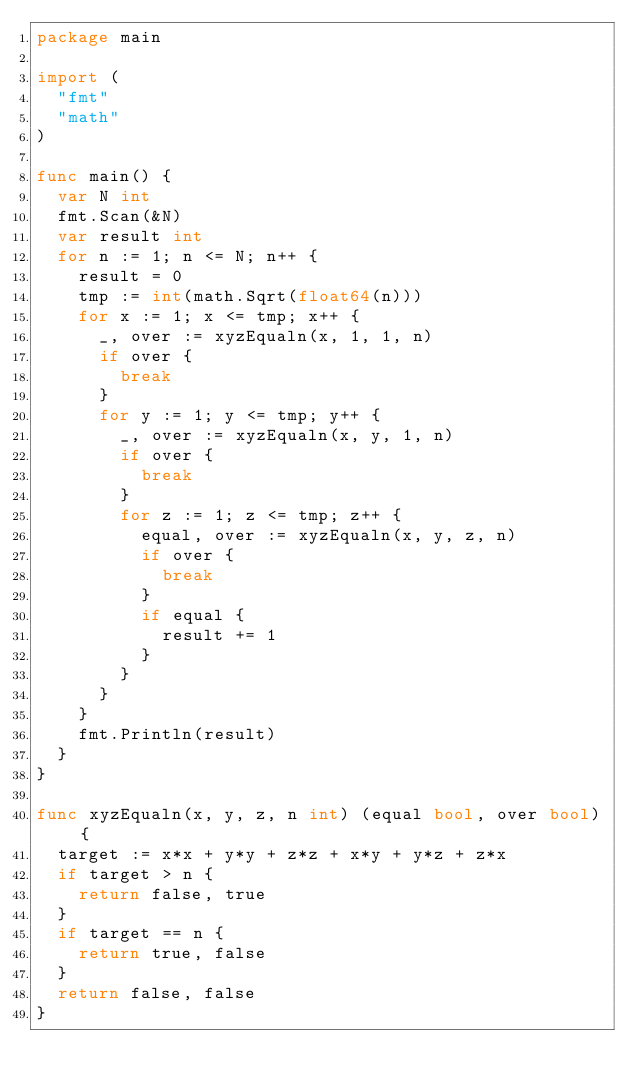Convert code to text. <code><loc_0><loc_0><loc_500><loc_500><_Go_>package main

import (
	"fmt"
	"math"
)

func main() {
	var N int
	fmt.Scan(&N)
	var result int
	for n := 1; n <= N; n++ {
		result = 0
		tmp := int(math.Sqrt(float64(n)))
		for x := 1; x <= tmp; x++ {
			_, over := xyzEqualn(x, 1, 1, n)
			if over {
				break
			}
			for y := 1; y <= tmp; y++ {
				_, over := xyzEqualn(x, y, 1, n)
				if over {
					break
				}
				for z := 1; z <= tmp; z++ {
					equal, over := xyzEqualn(x, y, z, n)
					if over {
						break
					}
					if equal {
						result += 1
					}
				}
			}
		}
		fmt.Println(result)
	}
}

func xyzEqualn(x, y, z, n int) (equal bool, over bool) {
	target := x*x + y*y + z*z + x*y + y*z + z*x
	if target > n {
		return false, true
	}
	if target == n {
		return true, false
	}
	return false, false
}
</code> 